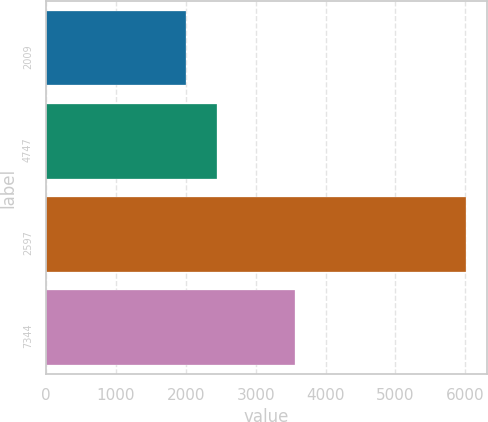Convert chart. <chart><loc_0><loc_0><loc_500><loc_500><bar_chart><fcel>2009<fcel>4747<fcel>2597<fcel>7344<nl><fcel>2007<fcel>2451<fcel>6012<fcel>3561<nl></chart> 